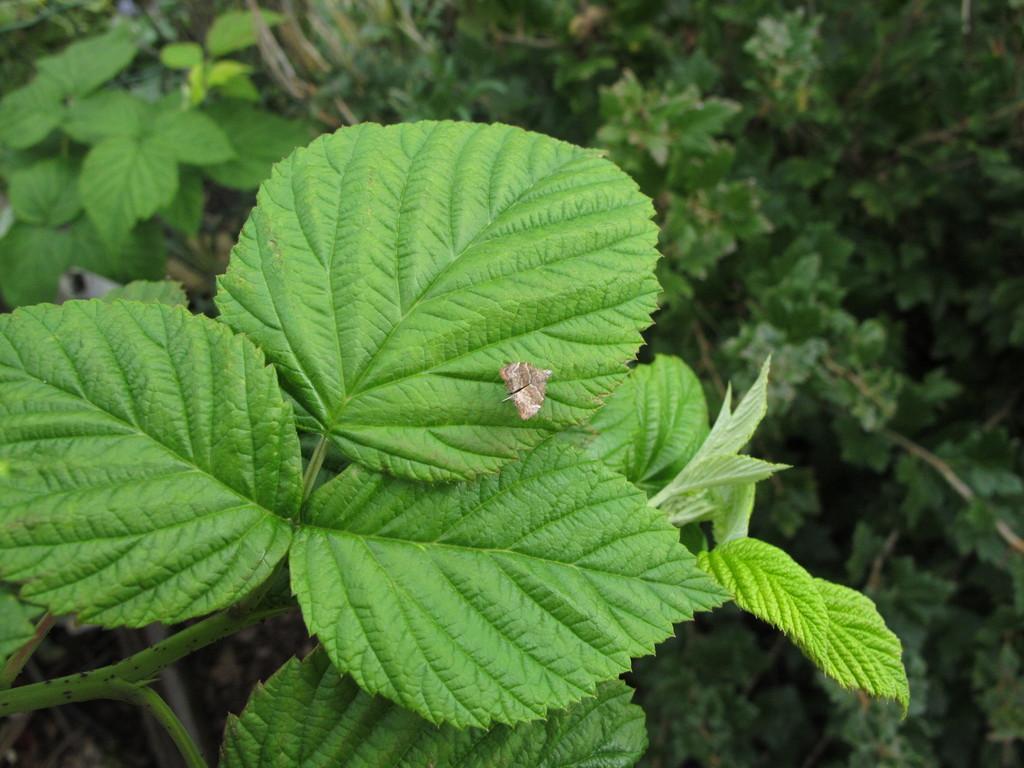Can you describe this image briefly? In this image I can see an insect on a plant. In the background I can see plants. 